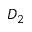Convert formula to latex. <formula><loc_0><loc_0><loc_500><loc_500>D _ { 2 }</formula> 